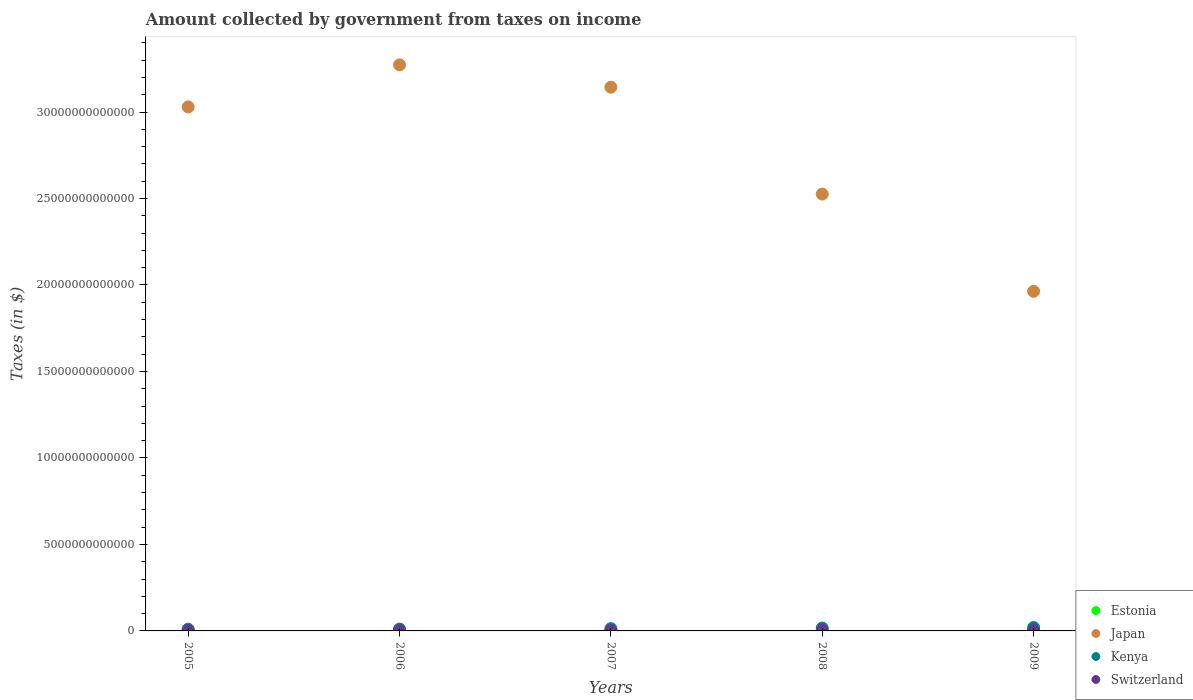How many different coloured dotlines are there?
Your answer should be very brief. 4. What is the amount collected by government from taxes on income in Kenya in 2009?
Offer a terse response. 1.94e+11. Across all years, what is the maximum amount collected by government from taxes on income in Switzerland?
Make the answer very short. 2.42e+1. Across all years, what is the minimum amount collected by government from taxes on income in Switzerland?
Provide a succinct answer. 1.63e+1. In which year was the amount collected by government from taxes on income in Switzerland maximum?
Ensure brevity in your answer.  2008. In which year was the amount collected by government from taxes on income in Kenya minimum?
Ensure brevity in your answer.  2005. What is the total amount collected by government from taxes on income in Estonia in the graph?
Ensure brevity in your answer.  2.34e+09. What is the difference between the amount collected by government from taxes on income in Estonia in 2005 and that in 2009?
Provide a short and direct response. -3.58e+07. What is the difference between the amount collected by government from taxes on income in Switzerland in 2006 and the amount collected by government from taxes on income in Kenya in 2009?
Your response must be concise. -1.76e+11. What is the average amount collected by government from taxes on income in Switzerland per year?
Your response must be concise. 2.04e+1. In the year 2008, what is the difference between the amount collected by government from taxes on income in Kenya and amount collected by government from taxes on income in Estonia?
Give a very brief answer. 1.65e+11. In how many years, is the amount collected by government from taxes on income in Switzerland greater than 2000000000000 $?
Your response must be concise. 0. What is the ratio of the amount collected by government from taxes on income in Estonia in 2005 to that in 2008?
Offer a terse response. 0.69. What is the difference between the highest and the second highest amount collected by government from taxes on income in Estonia?
Provide a short and direct response. 2.40e+07. What is the difference between the highest and the lowest amount collected by government from taxes on income in Japan?
Make the answer very short. 1.31e+13. Is it the case that in every year, the sum of the amount collected by government from taxes on income in Estonia and amount collected by government from taxes on income in Japan  is greater than the sum of amount collected by government from taxes on income in Switzerland and amount collected by government from taxes on income in Kenya?
Make the answer very short. Yes. Does the amount collected by government from taxes on income in Japan monotonically increase over the years?
Your response must be concise. No. What is the difference between two consecutive major ticks on the Y-axis?
Offer a terse response. 5.00e+12. Does the graph contain any zero values?
Give a very brief answer. No. Where does the legend appear in the graph?
Your response must be concise. Bottom right. What is the title of the graph?
Offer a terse response. Amount collected by government from taxes on income. Does "Argentina" appear as one of the legend labels in the graph?
Offer a very short reply. No. What is the label or title of the X-axis?
Your answer should be compact. Years. What is the label or title of the Y-axis?
Your answer should be compact. Taxes (in $). What is the Taxes (in $) of Estonia in 2005?
Offer a very short reply. 3.75e+08. What is the Taxes (in $) of Japan in 2005?
Offer a very short reply. 3.03e+13. What is the Taxes (in $) in Kenya in 2005?
Offer a very short reply. 9.93e+1. What is the Taxes (in $) in Switzerland in 2005?
Make the answer very short. 1.63e+1. What is the Taxes (in $) of Estonia in 2006?
Keep it short and to the point. 4.46e+08. What is the Taxes (in $) of Japan in 2006?
Provide a short and direct response. 3.27e+13. What is the Taxes (in $) of Kenya in 2006?
Make the answer very short. 1.09e+11. What is the Taxes (in $) in Switzerland in 2006?
Provide a succinct answer. 1.83e+1. What is the Taxes (in $) of Estonia in 2007?
Make the answer very short. 5.67e+08. What is the Taxes (in $) in Japan in 2007?
Provide a short and direct response. 3.14e+13. What is the Taxes (in $) in Kenya in 2007?
Your answer should be very brief. 1.31e+11. What is the Taxes (in $) of Switzerland in 2007?
Give a very brief answer. 1.97e+1. What is the Taxes (in $) in Estonia in 2008?
Keep it short and to the point. 5.43e+08. What is the Taxes (in $) in Japan in 2008?
Ensure brevity in your answer.  2.53e+13. What is the Taxes (in $) in Kenya in 2008?
Give a very brief answer. 1.65e+11. What is the Taxes (in $) in Switzerland in 2008?
Your answer should be very brief. 2.42e+1. What is the Taxes (in $) of Estonia in 2009?
Your answer should be compact. 4.11e+08. What is the Taxes (in $) in Japan in 2009?
Provide a succinct answer. 1.96e+13. What is the Taxes (in $) in Kenya in 2009?
Give a very brief answer. 1.94e+11. What is the Taxes (in $) in Switzerland in 2009?
Make the answer very short. 2.34e+1. Across all years, what is the maximum Taxes (in $) in Estonia?
Give a very brief answer. 5.67e+08. Across all years, what is the maximum Taxes (in $) of Japan?
Your answer should be compact. 3.27e+13. Across all years, what is the maximum Taxes (in $) of Kenya?
Make the answer very short. 1.94e+11. Across all years, what is the maximum Taxes (in $) in Switzerland?
Ensure brevity in your answer.  2.42e+1. Across all years, what is the minimum Taxes (in $) in Estonia?
Offer a terse response. 3.75e+08. Across all years, what is the minimum Taxes (in $) in Japan?
Your answer should be very brief. 1.96e+13. Across all years, what is the minimum Taxes (in $) of Kenya?
Provide a short and direct response. 9.93e+1. Across all years, what is the minimum Taxes (in $) of Switzerland?
Give a very brief answer. 1.63e+1. What is the total Taxes (in $) of Estonia in the graph?
Ensure brevity in your answer.  2.34e+09. What is the total Taxes (in $) of Japan in the graph?
Provide a short and direct response. 1.39e+14. What is the total Taxes (in $) of Kenya in the graph?
Make the answer very short. 6.99e+11. What is the total Taxes (in $) in Switzerland in the graph?
Ensure brevity in your answer.  1.02e+11. What is the difference between the Taxes (in $) in Estonia in 2005 and that in 2006?
Provide a short and direct response. -7.05e+07. What is the difference between the Taxes (in $) of Japan in 2005 and that in 2006?
Keep it short and to the point. -2.43e+12. What is the difference between the Taxes (in $) of Kenya in 2005 and that in 2006?
Offer a very short reply. -9.59e+09. What is the difference between the Taxes (in $) in Switzerland in 2005 and that in 2006?
Offer a very short reply. -1.97e+09. What is the difference between the Taxes (in $) of Estonia in 2005 and that in 2007?
Provide a short and direct response. -1.92e+08. What is the difference between the Taxes (in $) of Japan in 2005 and that in 2007?
Your answer should be compact. -1.14e+12. What is the difference between the Taxes (in $) of Kenya in 2005 and that in 2007?
Give a very brief answer. -3.21e+1. What is the difference between the Taxes (in $) of Switzerland in 2005 and that in 2007?
Your response must be concise. -3.41e+09. What is the difference between the Taxes (in $) of Estonia in 2005 and that in 2008?
Offer a terse response. -1.68e+08. What is the difference between the Taxes (in $) of Japan in 2005 and that in 2008?
Provide a short and direct response. 5.04e+12. What is the difference between the Taxes (in $) of Kenya in 2005 and that in 2008?
Keep it short and to the point. -6.58e+1. What is the difference between the Taxes (in $) in Switzerland in 2005 and that in 2008?
Your answer should be very brief. -7.92e+09. What is the difference between the Taxes (in $) of Estonia in 2005 and that in 2009?
Your answer should be very brief. -3.58e+07. What is the difference between the Taxes (in $) of Japan in 2005 and that in 2009?
Offer a very short reply. 1.07e+13. What is the difference between the Taxes (in $) of Kenya in 2005 and that in 2009?
Provide a short and direct response. -9.48e+1. What is the difference between the Taxes (in $) in Switzerland in 2005 and that in 2009?
Your answer should be very brief. -7.12e+09. What is the difference between the Taxes (in $) in Estonia in 2006 and that in 2007?
Provide a succinct answer. -1.21e+08. What is the difference between the Taxes (in $) in Japan in 2006 and that in 2007?
Your answer should be very brief. 1.29e+12. What is the difference between the Taxes (in $) of Kenya in 2006 and that in 2007?
Offer a terse response. -2.25e+1. What is the difference between the Taxes (in $) in Switzerland in 2006 and that in 2007?
Your answer should be very brief. -1.44e+09. What is the difference between the Taxes (in $) in Estonia in 2006 and that in 2008?
Make the answer very short. -9.74e+07. What is the difference between the Taxes (in $) of Japan in 2006 and that in 2008?
Make the answer very short. 7.47e+12. What is the difference between the Taxes (in $) of Kenya in 2006 and that in 2008?
Make the answer very short. -5.63e+1. What is the difference between the Taxes (in $) in Switzerland in 2006 and that in 2008?
Ensure brevity in your answer.  -5.94e+09. What is the difference between the Taxes (in $) in Estonia in 2006 and that in 2009?
Your answer should be compact. 3.47e+07. What is the difference between the Taxes (in $) of Japan in 2006 and that in 2009?
Make the answer very short. 1.31e+13. What is the difference between the Taxes (in $) in Kenya in 2006 and that in 2009?
Your answer should be very brief. -8.53e+1. What is the difference between the Taxes (in $) of Switzerland in 2006 and that in 2009?
Offer a terse response. -5.14e+09. What is the difference between the Taxes (in $) in Estonia in 2007 and that in 2008?
Keep it short and to the point. 2.40e+07. What is the difference between the Taxes (in $) of Japan in 2007 and that in 2008?
Provide a short and direct response. 6.18e+12. What is the difference between the Taxes (in $) in Kenya in 2007 and that in 2008?
Offer a terse response. -3.37e+1. What is the difference between the Taxes (in $) in Switzerland in 2007 and that in 2008?
Give a very brief answer. -4.50e+09. What is the difference between the Taxes (in $) of Estonia in 2007 and that in 2009?
Provide a short and direct response. 1.56e+08. What is the difference between the Taxes (in $) in Japan in 2007 and that in 2009?
Offer a very short reply. 1.18e+13. What is the difference between the Taxes (in $) in Kenya in 2007 and that in 2009?
Your response must be concise. -6.27e+1. What is the difference between the Taxes (in $) in Switzerland in 2007 and that in 2009?
Keep it short and to the point. -3.70e+09. What is the difference between the Taxes (in $) of Estonia in 2008 and that in 2009?
Provide a succinct answer. 1.32e+08. What is the difference between the Taxes (in $) in Japan in 2008 and that in 2009?
Provide a succinct answer. 5.62e+12. What is the difference between the Taxes (in $) of Kenya in 2008 and that in 2009?
Your answer should be very brief. -2.90e+1. What is the difference between the Taxes (in $) of Switzerland in 2008 and that in 2009?
Offer a terse response. 7.99e+08. What is the difference between the Taxes (in $) in Estonia in 2005 and the Taxes (in $) in Japan in 2006?
Your answer should be very brief. -3.27e+13. What is the difference between the Taxes (in $) of Estonia in 2005 and the Taxes (in $) of Kenya in 2006?
Ensure brevity in your answer.  -1.09e+11. What is the difference between the Taxes (in $) of Estonia in 2005 and the Taxes (in $) of Switzerland in 2006?
Your answer should be very brief. -1.79e+1. What is the difference between the Taxes (in $) in Japan in 2005 and the Taxes (in $) in Kenya in 2006?
Provide a short and direct response. 3.02e+13. What is the difference between the Taxes (in $) of Japan in 2005 and the Taxes (in $) of Switzerland in 2006?
Your answer should be compact. 3.03e+13. What is the difference between the Taxes (in $) of Kenya in 2005 and the Taxes (in $) of Switzerland in 2006?
Offer a terse response. 8.10e+1. What is the difference between the Taxes (in $) in Estonia in 2005 and the Taxes (in $) in Japan in 2007?
Your answer should be very brief. -3.14e+13. What is the difference between the Taxes (in $) of Estonia in 2005 and the Taxes (in $) of Kenya in 2007?
Your answer should be very brief. -1.31e+11. What is the difference between the Taxes (in $) of Estonia in 2005 and the Taxes (in $) of Switzerland in 2007?
Give a very brief answer. -1.93e+1. What is the difference between the Taxes (in $) of Japan in 2005 and the Taxes (in $) of Kenya in 2007?
Provide a short and direct response. 3.02e+13. What is the difference between the Taxes (in $) of Japan in 2005 and the Taxes (in $) of Switzerland in 2007?
Keep it short and to the point. 3.03e+13. What is the difference between the Taxes (in $) of Kenya in 2005 and the Taxes (in $) of Switzerland in 2007?
Keep it short and to the point. 7.96e+1. What is the difference between the Taxes (in $) of Estonia in 2005 and the Taxes (in $) of Japan in 2008?
Provide a succinct answer. -2.53e+13. What is the difference between the Taxes (in $) of Estonia in 2005 and the Taxes (in $) of Kenya in 2008?
Provide a succinct answer. -1.65e+11. What is the difference between the Taxes (in $) of Estonia in 2005 and the Taxes (in $) of Switzerland in 2008?
Ensure brevity in your answer.  -2.38e+1. What is the difference between the Taxes (in $) of Japan in 2005 and the Taxes (in $) of Kenya in 2008?
Offer a very short reply. 3.01e+13. What is the difference between the Taxes (in $) of Japan in 2005 and the Taxes (in $) of Switzerland in 2008?
Keep it short and to the point. 3.03e+13. What is the difference between the Taxes (in $) of Kenya in 2005 and the Taxes (in $) of Switzerland in 2008?
Ensure brevity in your answer.  7.51e+1. What is the difference between the Taxes (in $) in Estonia in 2005 and the Taxes (in $) in Japan in 2009?
Offer a very short reply. -1.96e+13. What is the difference between the Taxes (in $) of Estonia in 2005 and the Taxes (in $) of Kenya in 2009?
Offer a terse response. -1.94e+11. What is the difference between the Taxes (in $) of Estonia in 2005 and the Taxes (in $) of Switzerland in 2009?
Ensure brevity in your answer.  -2.30e+1. What is the difference between the Taxes (in $) in Japan in 2005 and the Taxes (in $) in Kenya in 2009?
Give a very brief answer. 3.01e+13. What is the difference between the Taxes (in $) of Japan in 2005 and the Taxes (in $) of Switzerland in 2009?
Offer a terse response. 3.03e+13. What is the difference between the Taxes (in $) of Kenya in 2005 and the Taxes (in $) of Switzerland in 2009?
Make the answer very short. 7.59e+1. What is the difference between the Taxes (in $) in Estonia in 2006 and the Taxes (in $) in Japan in 2007?
Provide a short and direct response. -3.14e+13. What is the difference between the Taxes (in $) of Estonia in 2006 and the Taxes (in $) of Kenya in 2007?
Give a very brief answer. -1.31e+11. What is the difference between the Taxes (in $) in Estonia in 2006 and the Taxes (in $) in Switzerland in 2007?
Ensure brevity in your answer.  -1.93e+1. What is the difference between the Taxes (in $) in Japan in 2006 and the Taxes (in $) in Kenya in 2007?
Ensure brevity in your answer.  3.26e+13. What is the difference between the Taxes (in $) of Japan in 2006 and the Taxes (in $) of Switzerland in 2007?
Make the answer very short. 3.27e+13. What is the difference between the Taxes (in $) in Kenya in 2006 and the Taxes (in $) in Switzerland in 2007?
Your answer should be very brief. 8.92e+1. What is the difference between the Taxes (in $) of Estonia in 2006 and the Taxes (in $) of Japan in 2008?
Offer a terse response. -2.53e+13. What is the difference between the Taxes (in $) in Estonia in 2006 and the Taxes (in $) in Kenya in 2008?
Offer a terse response. -1.65e+11. What is the difference between the Taxes (in $) in Estonia in 2006 and the Taxes (in $) in Switzerland in 2008?
Keep it short and to the point. -2.38e+1. What is the difference between the Taxes (in $) in Japan in 2006 and the Taxes (in $) in Kenya in 2008?
Provide a succinct answer. 3.26e+13. What is the difference between the Taxes (in $) in Japan in 2006 and the Taxes (in $) in Switzerland in 2008?
Provide a succinct answer. 3.27e+13. What is the difference between the Taxes (in $) of Kenya in 2006 and the Taxes (in $) of Switzerland in 2008?
Give a very brief answer. 8.47e+1. What is the difference between the Taxes (in $) in Estonia in 2006 and the Taxes (in $) in Japan in 2009?
Provide a short and direct response. -1.96e+13. What is the difference between the Taxes (in $) in Estonia in 2006 and the Taxes (in $) in Kenya in 2009?
Make the answer very short. -1.94e+11. What is the difference between the Taxes (in $) of Estonia in 2006 and the Taxes (in $) of Switzerland in 2009?
Provide a succinct answer. -2.30e+1. What is the difference between the Taxes (in $) in Japan in 2006 and the Taxes (in $) in Kenya in 2009?
Provide a short and direct response. 3.25e+13. What is the difference between the Taxes (in $) of Japan in 2006 and the Taxes (in $) of Switzerland in 2009?
Your answer should be compact. 3.27e+13. What is the difference between the Taxes (in $) in Kenya in 2006 and the Taxes (in $) in Switzerland in 2009?
Offer a very short reply. 8.55e+1. What is the difference between the Taxes (in $) of Estonia in 2007 and the Taxes (in $) of Japan in 2008?
Make the answer very short. -2.53e+13. What is the difference between the Taxes (in $) of Estonia in 2007 and the Taxes (in $) of Kenya in 2008?
Provide a succinct answer. -1.65e+11. What is the difference between the Taxes (in $) of Estonia in 2007 and the Taxes (in $) of Switzerland in 2008?
Make the answer very short. -2.37e+1. What is the difference between the Taxes (in $) in Japan in 2007 and the Taxes (in $) in Kenya in 2008?
Offer a terse response. 3.13e+13. What is the difference between the Taxes (in $) of Japan in 2007 and the Taxes (in $) of Switzerland in 2008?
Your response must be concise. 3.14e+13. What is the difference between the Taxes (in $) of Kenya in 2007 and the Taxes (in $) of Switzerland in 2008?
Offer a very short reply. 1.07e+11. What is the difference between the Taxes (in $) of Estonia in 2007 and the Taxes (in $) of Japan in 2009?
Make the answer very short. -1.96e+13. What is the difference between the Taxes (in $) in Estonia in 2007 and the Taxes (in $) in Kenya in 2009?
Keep it short and to the point. -1.94e+11. What is the difference between the Taxes (in $) of Estonia in 2007 and the Taxes (in $) of Switzerland in 2009?
Keep it short and to the point. -2.29e+1. What is the difference between the Taxes (in $) of Japan in 2007 and the Taxes (in $) of Kenya in 2009?
Give a very brief answer. 3.12e+13. What is the difference between the Taxes (in $) in Japan in 2007 and the Taxes (in $) in Switzerland in 2009?
Ensure brevity in your answer.  3.14e+13. What is the difference between the Taxes (in $) of Kenya in 2007 and the Taxes (in $) of Switzerland in 2009?
Give a very brief answer. 1.08e+11. What is the difference between the Taxes (in $) of Estonia in 2008 and the Taxes (in $) of Japan in 2009?
Provide a short and direct response. -1.96e+13. What is the difference between the Taxes (in $) in Estonia in 2008 and the Taxes (in $) in Kenya in 2009?
Your response must be concise. -1.94e+11. What is the difference between the Taxes (in $) of Estonia in 2008 and the Taxes (in $) of Switzerland in 2009?
Offer a very short reply. -2.29e+1. What is the difference between the Taxes (in $) in Japan in 2008 and the Taxes (in $) in Kenya in 2009?
Provide a succinct answer. 2.51e+13. What is the difference between the Taxes (in $) in Japan in 2008 and the Taxes (in $) in Switzerland in 2009?
Give a very brief answer. 2.52e+13. What is the difference between the Taxes (in $) in Kenya in 2008 and the Taxes (in $) in Switzerland in 2009?
Provide a succinct answer. 1.42e+11. What is the average Taxes (in $) in Estonia per year?
Offer a very short reply. 4.68e+08. What is the average Taxes (in $) of Japan per year?
Offer a very short reply. 2.79e+13. What is the average Taxes (in $) in Kenya per year?
Provide a succinct answer. 1.40e+11. What is the average Taxes (in $) in Switzerland per year?
Ensure brevity in your answer.  2.04e+1. In the year 2005, what is the difference between the Taxes (in $) in Estonia and Taxes (in $) in Japan?
Ensure brevity in your answer.  -3.03e+13. In the year 2005, what is the difference between the Taxes (in $) in Estonia and Taxes (in $) in Kenya?
Your response must be concise. -9.89e+1. In the year 2005, what is the difference between the Taxes (in $) in Estonia and Taxes (in $) in Switzerland?
Provide a succinct answer. -1.59e+1. In the year 2005, what is the difference between the Taxes (in $) of Japan and Taxes (in $) of Kenya?
Provide a short and direct response. 3.02e+13. In the year 2005, what is the difference between the Taxes (in $) in Japan and Taxes (in $) in Switzerland?
Offer a very short reply. 3.03e+13. In the year 2005, what is the difference between the Taxes (in $) in Kenya and Taxes (in $) in Switzerland?
Your answer should be very brief. 8.30e+1. In the year 2006, what is the difference between the Taxes (in $) in Estonia and Taxes (in $) in Japan?
Give a very brief answer. -3.27e+13. In the year 2006, what is the difference between the Taxes (in $) of Estonia and Taxes (in $) of Kenya?
Ensure brevity in your answer.  -1.08e+11. In the year 2006, what is the difference between the Taxes (in $) in Estonia and Taxes (in $) in Switzerland?
Give a very brief answer. -1.78e+1. In the year 2006, what is the difference between the Taxes (in $) of Japan and Taxes (in $) of Kenya?
Keep it short and to the point. 3.26e+13. In the year 2006, what is the difference between the Taxes (in $) of Japan and Taxes (in $) of Switzerland?
Your answer should be compact. 3.27e+13. In the year 2006, what is the difference between the Taxes (in $) of Kenya and Taxes (in $) of Switzerland?
Ensure brevity in your answer.  9.06e+1. In the year 2007, what is the difference between the Taxes (in $) of Estonia and Taxes (in $) of Japan?
Ensure brevity in your answer.  -3.14e+13. In the year 2007, what is the difference between the Taxes (in $) of Estonia and Taxes (in $) of Kenya?
Ensure brevity in your answer.  -1.31e+11. In the year 2007, what is the difference between the Taxes (in $) of Estonia and Taxes (in $) of Switzerland?
Your response must be concise. -1.91e+1. In the year 2007, what is the difference between the Taxes (in $) in Japan and Taxes (in $) in Kenya?
Provide a succinct answer. 3.13e+13. In the year 2007, what is the difference between the Taxes (in $) in Japan and Taxes (in $) in Switzerland?
Offer a very short reply. 3.14e+13. In the year 2007, what is the difference between the Taxes (in $) of Kenya and Taxes (in $) of Switzerland?
Your answer should be very brief. 1.12e+11. In the year 2008, what is the difference between the Taxes (in $) of Estonia and Taxes (in $) of Japan?
Ensure brevity in your answer.  -2.53e+13. In the year 2008, what is the difference between the Taxes (in $) in Estonia and Taxes (in $) in Kenya?
Ensure brevity in your answer.  -1.65e+11. In the year 2008, what is the difference between the Taxes (in $) in Estonia and Taxes (in $) in Switzerland?
Give a very brief answer. -2.37e+1. In the year 2008, what is the difference between the Taxes (in $) of Japan and Taxes (in $) of Kenya?
Ensure brevity in your answer.  2.51e+13. In the year 2008, what is the difference between the Taxes (in $) in Japan and Taxes (in $) in Switzerland?
Offer a terse response. 2.52e+13. In the year 2008, what is the difference between the Taxes (in $) in Kenya and Taxes (in $) in Switzerland?
Provide a short and direct response. 1.41e+11. In the year 2009, what is the difference between the Taxes (in $) of Estonia and Taxes (in $) of Japan?
Give a very brief answer. -1.96e+13. In the year 2009, what is the difference between the Taxes (in $) in Estonia and Taxes (in $) in Kenya?
Your answer should be very brief. -1.94e+11. In the year 2009, what is the difference between the Taxes (in $) of Estonia and Taxes (in $) of Switzerland?
Your answer should be very brief. -2.30e+1. In the year 2009, what is the difference between the Taxes (in $) of Japan and Taxes (in $) of Kenya?
Offer a terse response. 1.94e+13. In the year 2009, what is the difference between the Taxes (in $) in Japan and Taxes (in $) in Switzerland?
Give a very brief answer. 1.96e+13. In the year 2009, what is the difference between the Taxes (in $) of Kenya and Taxes (in $) of Switzerland?
Offer a very short reply. 1.71e+11. What is the ratio of the Taxes (in $) in Estonia in 2005 to that in 2006?
Your answer should be compact. 0.84. What is the ratio of the Taxes (in $) of Japan in 2005 to that in 2006?
Offer a very short reply. 0.93. What is the ratio of the Taxes (in $) of Kenya in 2005 to that in 2006?
Provide a succinct answer. 0.91. What is the ratio of the Taxes (in $) of Switzerland in 2005 to that in 2006?
Provide a short and direct response. 0.89. What is the ratio of the Taxes (in $) of Estonia in 2005 to that in 2007?
Your response must be concise. 0.66. What is the ratio of the Taxes (in $) in Japan in 2005 to that in 2007?
Provide a short and direct response. 0.96. What is the ratio of the Taxes (in $) in Kenya in 2005 to that in 2007?
Provide a short and direct response. 0.76. What is the ratio of the Taxes (in $) in Switzerland in 2005 to that in 2007?
Offer a terse response. 0.83. What is the ratio of the Taxes (in $) of Estonia in 2005 to that in 2008?
Your answer should be compact. 0.69. What is the ratio of the Taxes (in $) of Japan in 2005 to that in 2008?
Give a very brief answer. 1.2. What is the ratio of the Taxes (in $) in Kenya in 2005 to that in 2008?
Offer a very short reply. 0.6. What is the ratio of the Taxes (in $) of Switzerland in 2005 to that in 2008?
Keep it short and to the point. 0.67. What is the ratio of the Taxes (in $) in Estonia in 2005 to that in 2009?
Offer a terse response. 0.91. What is the ratio of the Taxes (in $) of Japan in 2005 to that in 2009?
Your answer should be very brief. 1.54. What is the ratio of the Taxes (in $) in Kenya in 2005 to that in 2009?
Ensure brevity in your answer.  0.51. What is the ratio of the Taxes (in $) of Switzerland in 2005 to that in 2009?
Give a very brief answer. 0.7. What is the ratio of the Taxes (in $) of Estonia in 2006 to that in 2007?
Your answer should be very brief. 0.79. What is the ratio of the Taxes (in $) in Japan in 2006 to that in 2007?
Your response must be concise. 1.04. What is the ratio of the Taxes (in $) of Kenya in 2006 to that in 2007?
Your answer should be compact. 0.83. What is the ratio of the Taxes (in $) of Switzerland in 2006 to that in 2007?
Give a very brief answer. 0.93. What is the ratio of the Taxes (in $) in Estonia in 2006 to that in 2008?
Keep it short and to the point. 0.82. What is the ratio of the Taxes (in $) in Japan in 2006 to that in 2008?
Ensure brevity in your answer.  1.3. What is the ratio of the Taxes (in $) of Kenya in 2006 to that in 2008?
Offer a very short reply. 0.66. What is the ratio of the Taxes (in $) of Switzerland in 2006 to that in 2008?
Provide a short and direct response. 0.75. What is the ratio of the Taxes (in $) of Estonia in 2006 to that in 2009?
Offer a very short reply. 1.08. What is the ratio of the Taxes (in $) of Japan in 2006 to that in 2009?
Ensure brevity in your answer.  1.67. What is the ratio of the Taxes (in $) in Kenya in 2006 to that in 2009?
Your answer should be compact. 0.56. What is the ratio of the Taxes (in $) of Switzerland in 2006 to that in 2009?
Offer a terse response. 0.78. What is the ratio of the Taxes (in $) of Estonia in 2007 to that in 2008?
Provide a short and direct response. 1.04. What is the ratio of the Taxes (in $) in Japan in 2007 to that in 2008?
Keep it short and to the point. 1.24. What is the ratio of the Taxes (in $) of Kenya in 2007 to that in 2008?
Your answer should be compact. 0.8. What is the ratio of the Taxes (in $) in Switzerland in 2007 to that in 2008?
Offer a very short reply. 0.81. What is the ratio of the Taxes (in $) of Estonia in 2007 to that in 2009?
Offer a terse response. 1.38. What is the ratio of the Taxes (in $) in Japan in 2007 to that in 2009?
Ensure brevity in your answer.  1.6. What is the ratio of the Taxes (in $) of Kenya in 2007 to that in 2009?
Make the answer very short. 0.68. What is the ratio of the Taxes (in $) in Switzerland in 2007 to that in 2009?
Offer a very short reply. 0.84. What is the ratio of the Taxes (in $) of Estonia in 2008 to that in 2009?
Offer a terse response. 1.32. What is the ratio of the Taxes (in $) of Japan in 2008 to that in 2009?
Your response must be concise. 1.29. What is the ratio of the Taxes (in $) of Kenya in 2008 to that in 2009?
Your answer should be compact. 0.85. What is the ratio of the Taxes (in $) in Switzerland in 2008 to that in 2009?
Give a very brief answer. 1.03. What is the difference between the highest and the second highest Taxes (in $) in Estonia?
Make the answer very short. 2.40e+07. What is the difference between the highest and the second highest Taxes (in $) in Japan?
Offer a terse response. 1.29e+12. What is the difference between the highest and the second highest Taxes (in $) in Kenya?
Ensure brevity in your answer.  2.90e+1. What is the difference between the highest and the second highest Taxes (in $) in Switzerland?
Make the answer very short. 7.99e+08. What is the difference between the highest and the lowest Taxes (in $) in Estonia?
Offer a terse response. 1.92e+08. What is the difference between the highest and the lowest Taxes (in $) in Japan?
Provide a succinct answer. 1.31e+13. What is the difference between the highest and the lowest Taxes (in $) of Kenya?
Offer a terse response. 9.48e+1. What is the difference between the highest and the lowest Taxes (in $) of Switzerland?
Offer a very short reply. 7.92e+09. 